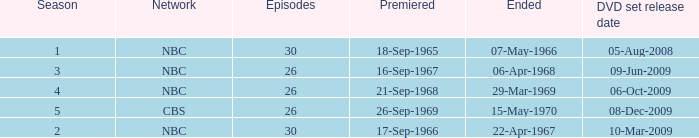When dis cbs release the DVD set? 08-Dec-2009. 